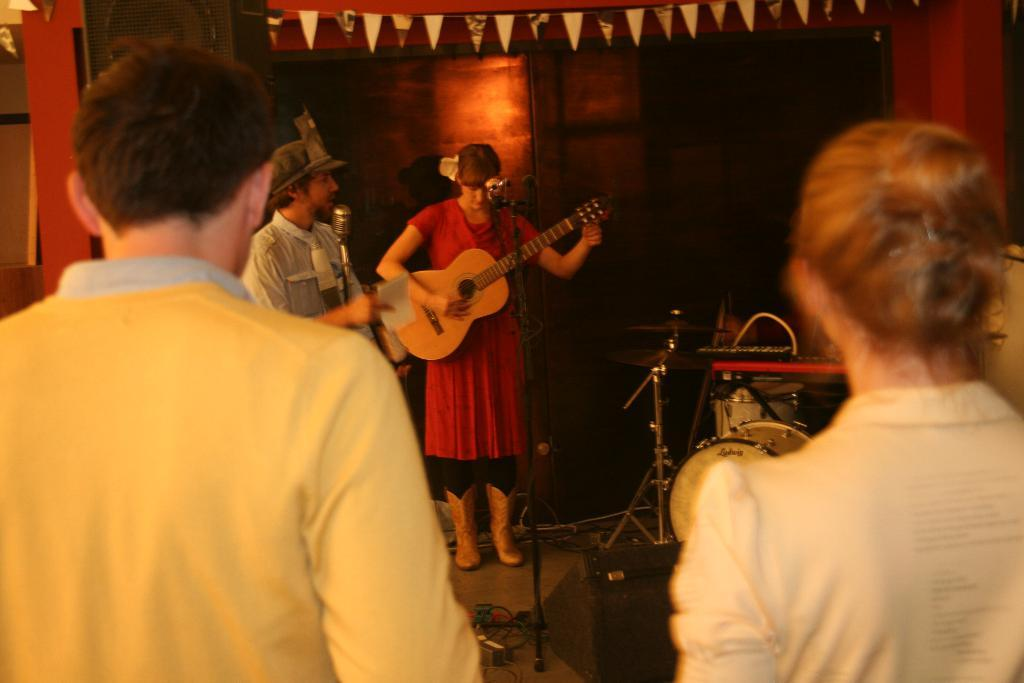What is happening in the image? There are people standing in the image. What is the woman holding in her hand? The woman is holding a guitar in her hand. Can you describe the man standing beside the woman? A man is standing beside the woman. What type of lipstick is the man wearing in the image? There is no mention of lipstick or any cosmetics in the image, as it features people standing and a woman holding a guitar. 